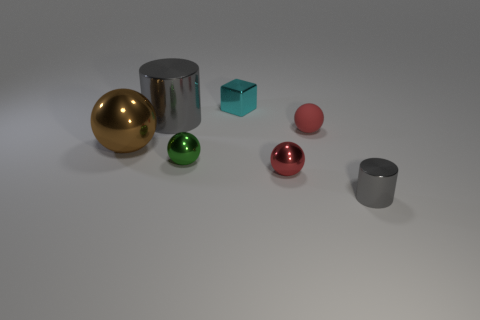The red shiny thing that is the same size as the green metallic thing is what shape?
Your answer should be very brief. Sphere. Are there the same number of big things that are in front of the big gray metallic object and tiny shiny things that are behind the tiny green thing?
Provide a succinct answer. Yes. There is a gray metal thing that is on the right side of the metallic cylinder that is left of the matte ball; how big is it?
Provide a succinct answer. Small. Is there a gray thing that has the same size as the brown thing?
Offer a terse response. Yes. There is a tiny cube that is the same material as the tiny gray cylinder; what color is it?
Ensure brevity in your answer.  Cyan. Is the number of gray objects less than the number of small spheres?
Offer a very short reply. Yes. What material is the sphere that is behind the green metal sphere and on the right side of the large shiny sphere?
Provide a succinct answer. Rubber. There is a tiny metallic object that is behind the small rubber thing; is there a gray metal thing that is to the left of it?
Your response must be concise. Yes. What number of other cylinders are the same color as the big cylinder?
Make the answer very short. 1. There is a tiny cylinder that is the same color as the big metallic cylinder; what material is it?
Make the answer very short. Metal. 